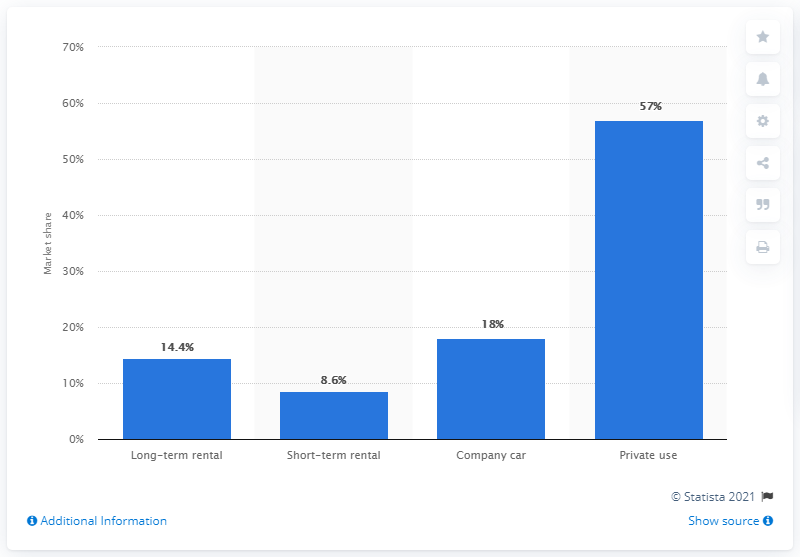Highlight a few significant elements in this photo. In the first nine months of 2019, private cars accounted for approximately 57% of Italy's car market. 